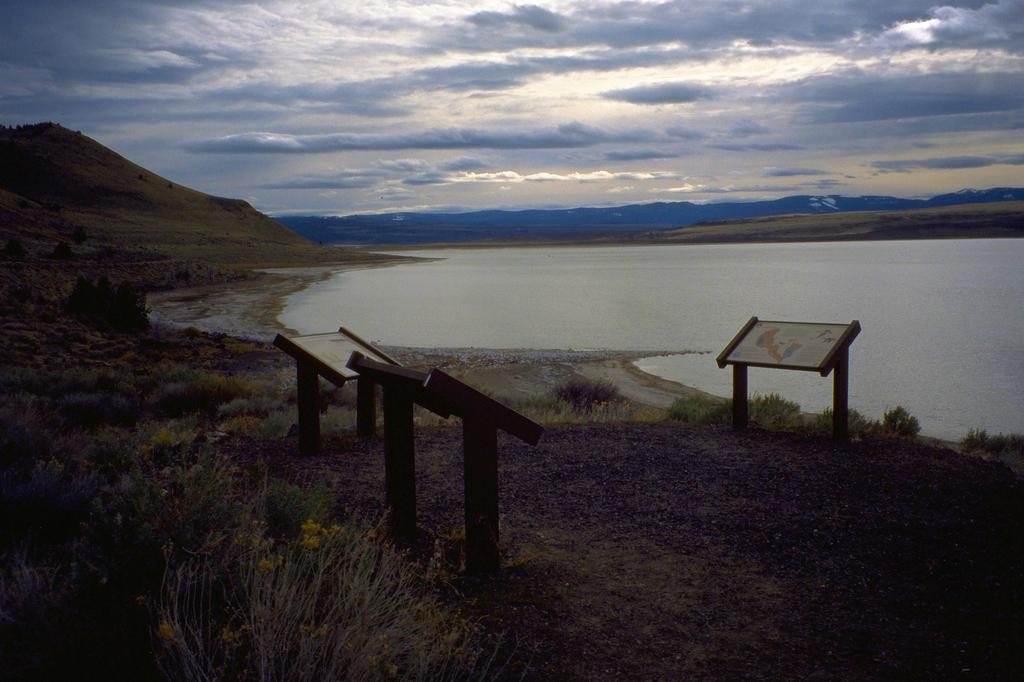What is located in the center of the image? There are poles, boards, plants, grass, and water in the center of the image. Can you describe the elements in the center of the image? The center of the image features poles, boards, plants, grass, and water. What is visible in the background of the image? There is sky, clouds, and hills visible in the background of the image. How many ladybugs are crawling on the poles in the image? There are no ladybugs present in the image; the center of the image features poles, boards, plants, grass, and water. What type of room is depicted in the image? The image does not depict a room; it features a landscape with poles, boards, plants, grass, water, sky, clouds, and hills. 